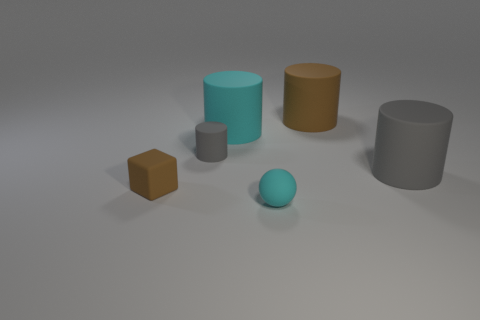Subtract all tiny cylinders. How many cylinders are left? 3 Subtract all brown blocks. How many blue balls are left? 0 Subtract all gray cylinders. How many cylinders are left? 2 Subtract all big brown shiny things. Subtract all tiny brown things. How many objects are left? 5 Add 6 big cyan rubber cylinders. How many big cyan rubber cylinders are left? 7 Add 6 tiny brown rubber blocks. How many tiny brown rubber blocks exist? 7 Add 3 gray metallic cubes. How many objects exist? 9 Subtract 0 blue cylinders. How many objects are left? 6 Subtract all cylinders. How many objects are left? 2 Subtract 2 cylinders. How many cylinders are left? 2 